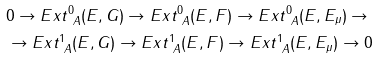<formula> <loc_0><loc_0><loc_500><loc_500>& 0 \to E x t ^ { 0 } _ { \ A } ( E , G ) \to E x t ^ { 0 } _ { \ A } ( E , F ) \to E x t ^ { 0 } _ { \ A } ( E , E _ { \mu } ) \to \\ & \to E x t ^ { 1 } _ { \ A } ( E , G ) \to E x t ^ { 1 } _ { \ A } ( E , F ) \to E x t ^ { 1 } _ { \ A } ( E , E _ { \mu } ) \to 0</formula> 